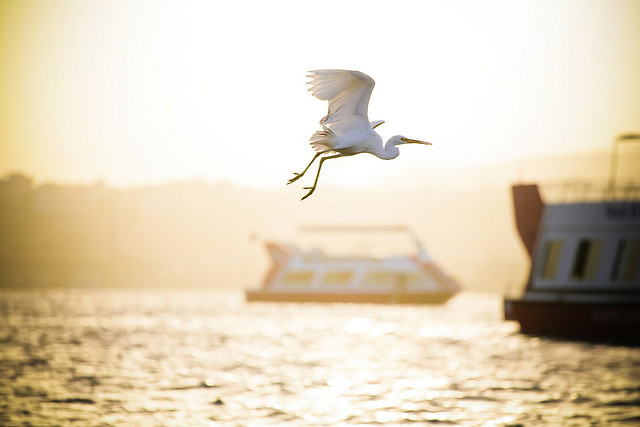<image>What type of bird is in the photo? I am not sure what type of bird is in the photo. It could be a pelican, albatross, crane, seagull, gull, or flamingo. What type of bird is in the photo? I am not sure what type of bird is in the photo. It can be seen as 'pelican', 'albatross', 'crane', 'seagull' or 'flamingo'. 